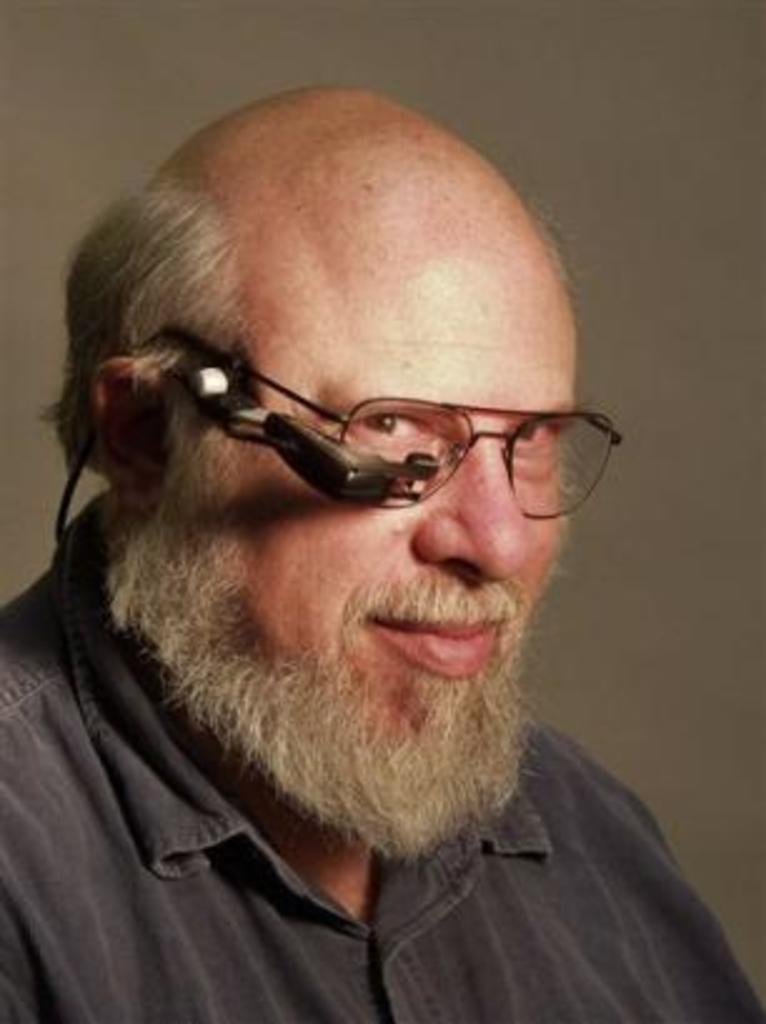Could you give a brief overview of what you see in this image? In this image we can see a man and the man is wearing spectacle. There is an object near the spectacle. 